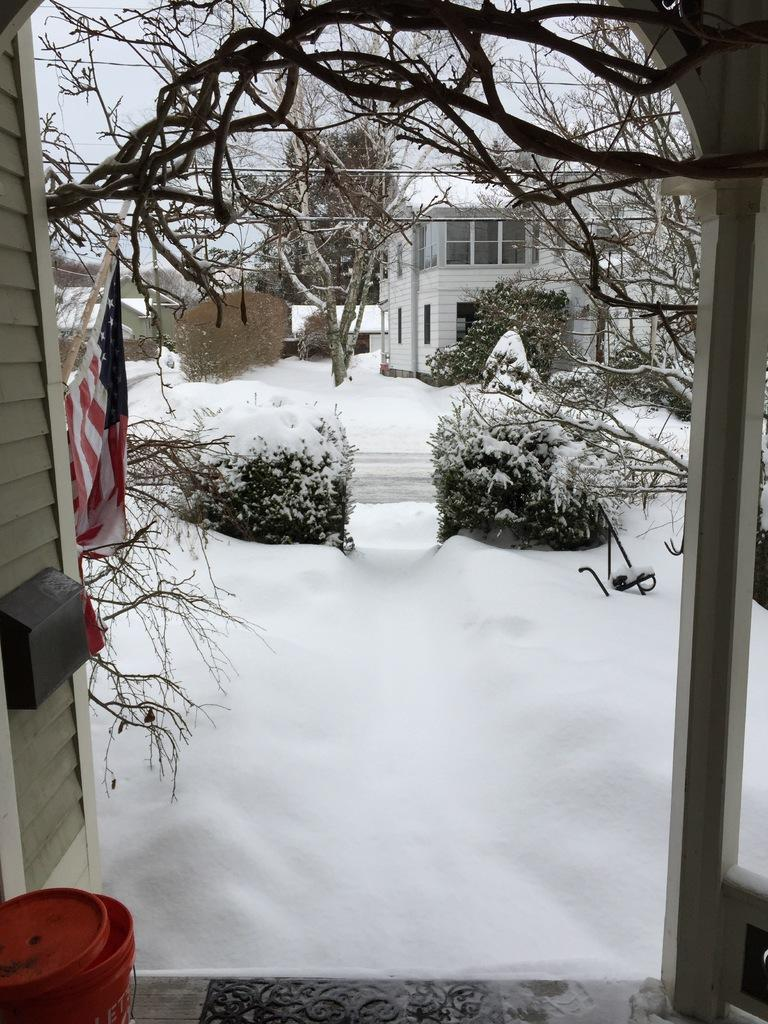What is the primary feature of the image's environment? There is snow in the image. What object can be seen on the left side of the image? There is a red color bucket on the left side of the image. What other object is on the left side of the image? There is a flag on the left side of the image. What can be seen in the background of the image? There are trees, a house with windows, and the sky visible in the background of the image. Where is the zoo located in the image? There is no zoo present in the image. How do the trees maintain their balance in the snowy environment? The trees do not need to maintain balance; they are stationary and rooted in the ground. 